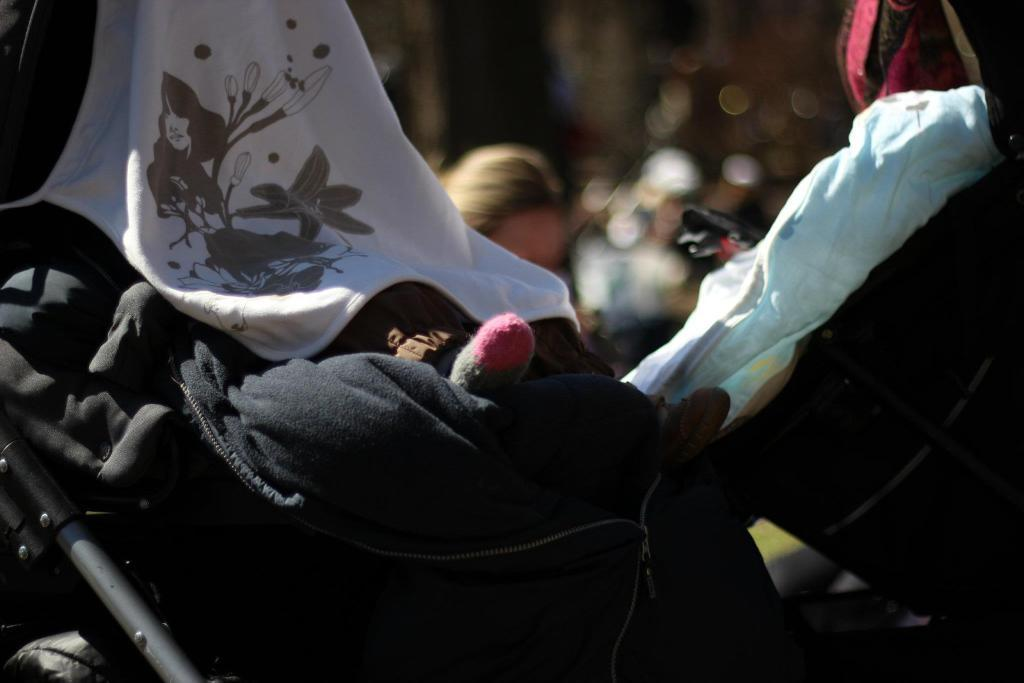What is the main object in the center of the image? There is a pram in the center of the image. What is placed on the pram? Clothes are placed on the pram. Can you describe the person in the background of the image? Unfortunately, the facts provided do not give any details about the person in the background. What type of stitch is used to sew the clothes on the pram? There is no information about the stitch used to sew the clothes on the pram in the image. Can you see any mice running around the pram in the image? There are no mice present in the image. 